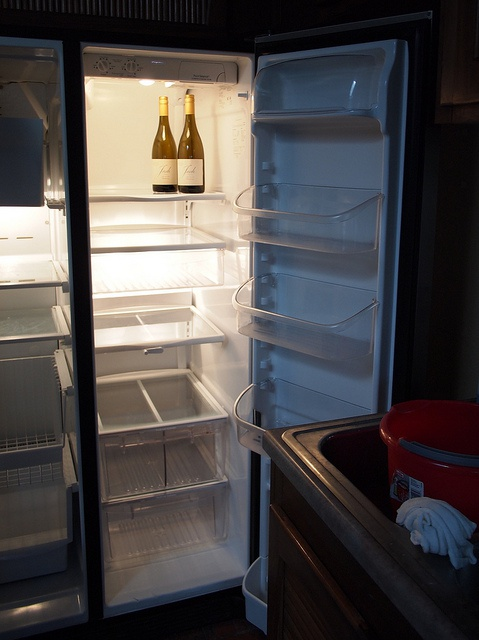Describe the objects in this image and their specific colors. I can see refrigerator in black, gray, ivory, and tan tones, sink in black, gray, and maroon tones, bottle in black, tan, and maroon tones, and bottle in black, khaki, maroon, olive, and tan tones in this image. 